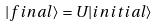<formula> <loc_0><loc_0><loc_500><loc_500>| f i n a l \rangle = U | i n i t i a l \rangle</formula> 